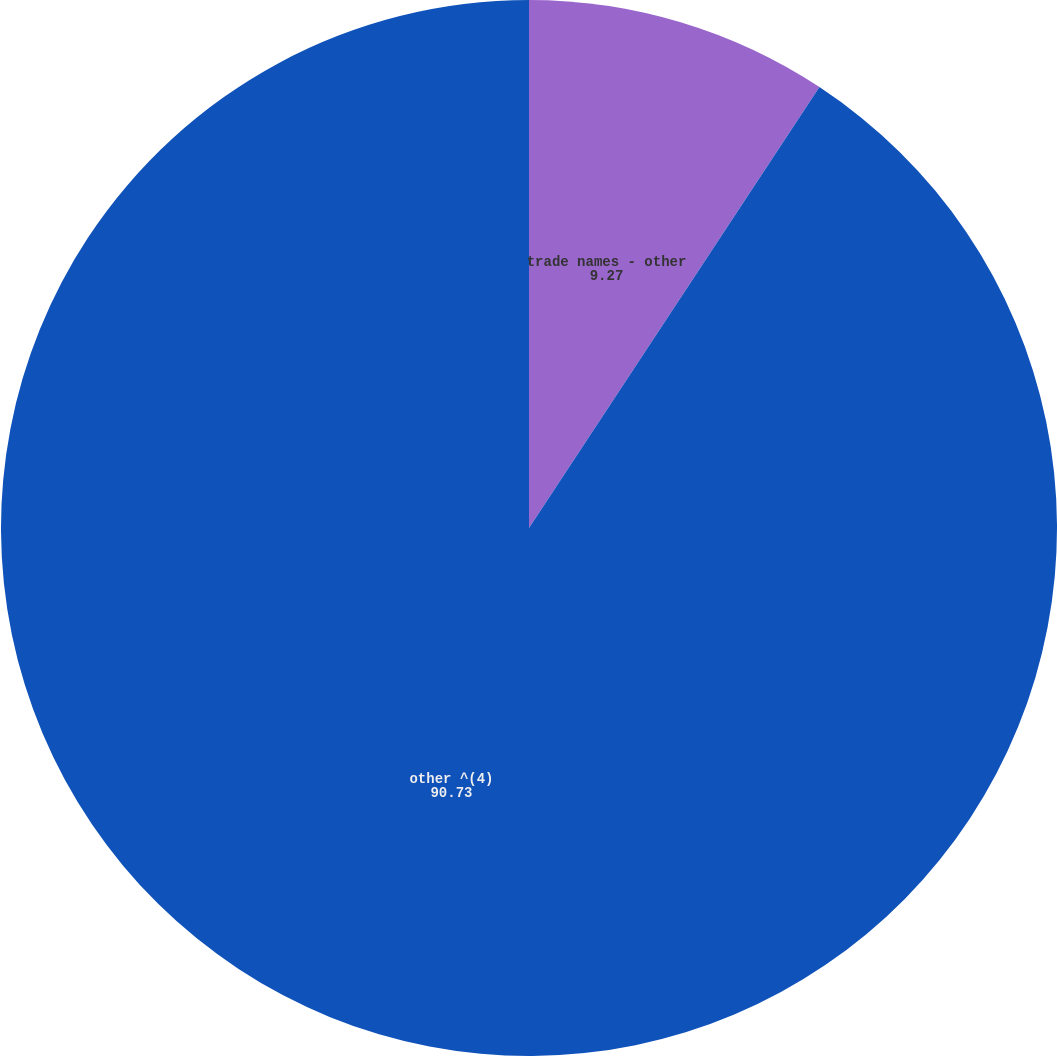Convert chart to OTSL. <chart><loc_0><loc_0><loc_500><loc_500><pie_chart><fcel>trade names - other<fcel>other ^(4)<nl><fcel>9.27%<fcel>90.73%<nl></chart> 